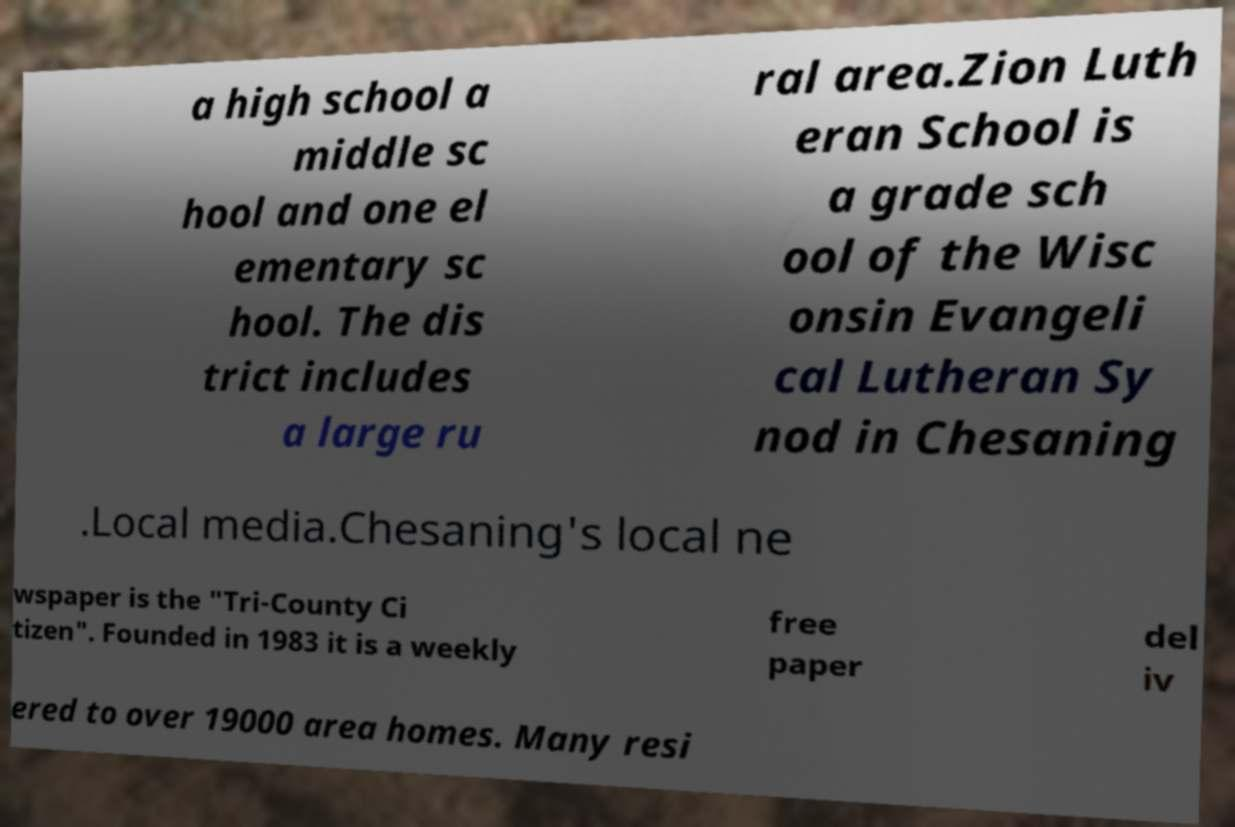There's text embedded in this image that I need extracted. Can you transcribe it verbatim? a high school a middle sc hool and one el ementary sc hool. The dis trict includes a large ru ral area.Zion Luth eran School is a grade sch ool of the Wisc onsin Evangeli cal Lutheran Sy nod in Chesaning .Local media.Chesaning's local ne wspaper is the "Tri-County Ci tizen". Founded in 1983 it is a weekly free paper del iv ered to over 19000 area homes. Many resi 